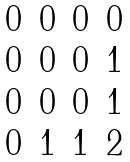<formula> <loc_0><loc_0><loc_500><loc_500>\begin{matrix} 0 & 0 & 0 & 0 \\ 0 & 0 & 0 & 1 \\ 0 & 0 & 0 & 1 \\ 0 & 1 & 1 & 2 \end{matrix}</formula> 